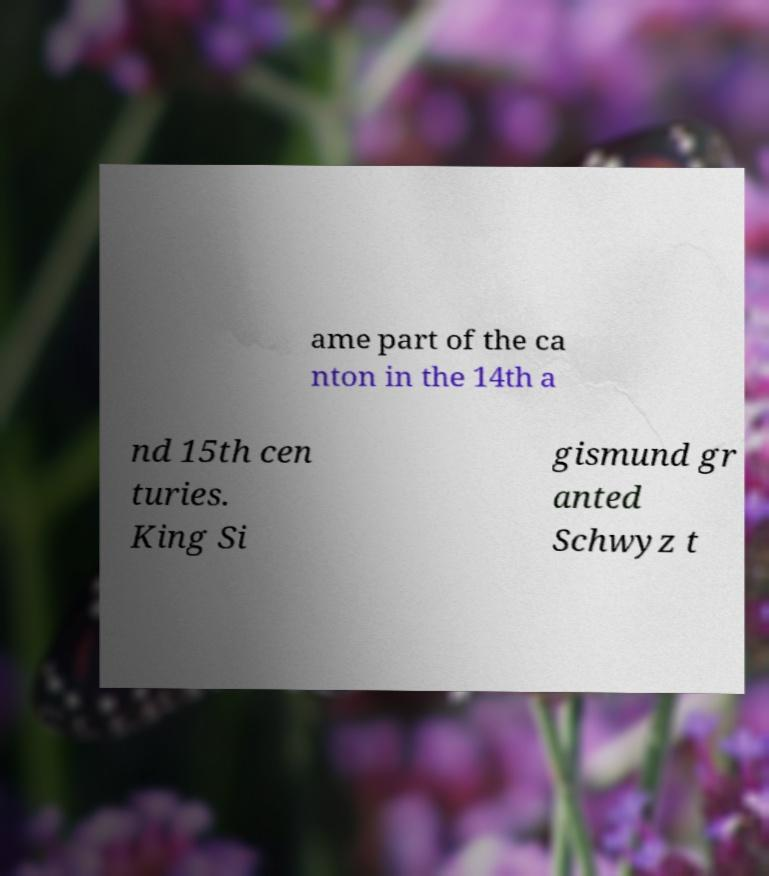Could you assist in decoding the text presented in this image and type it out clearly? ame part of the ca nton in the 14th a nd 15th cen turies. King Si gismund gr anted Schwyz t 